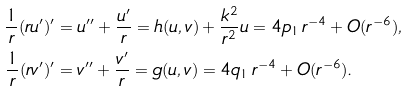<formula> <loc_0><loc_0><loc_500><loc_500>\frac { 1 } { r } ( r u ^ { \prime } ) ^ { \prime } & = u ^ { \prime \prime } + \frac { u ^ { \prime } } { r } = h ( u , v ) + \frac { k ^ { 2 } } { r ^ { 2 } } u = 4 p _ { 1 } \, r ^ { - 4 } + O ( r ^ { - 6 } ) , \\ \frac { 1 } { r } ( r v ^ { \prime } ) ^ { \prime } & = v ^ { \prime \prime } + \frac { v ^ { \prime } } { r } = g ( u , v ) = 4 q _ { 1 } \, r ^ { - 4 } + O ( r ^ { - 6 } ) .</formula> 